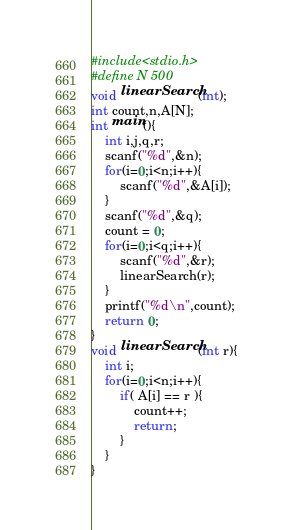<code> <loc_0><loc_0><loc_500><loc_500><_C_>#include<stdio.h>
#define N 500
void linearSearch(int);
int count,n,A[N];
int main(){
	int i,j,q,r;
	scanf("%d",&n);
	for(i=0;i<n;i++){
		scanf("%d",&A[i]);
	}
	scanf("%d",&q);
	count = 0;
	for(i=0;i<q;i++){
		scanf("%d",&r);
		linearSearch(r);
	}
	printf("%d\n",count);
	return 0;
}
void linearSearch(int r){
	int i;
	for(i=0;i<n;i++){
		if( A[i] == r ){
			count++;
			return;
		}
	}
}</code> 